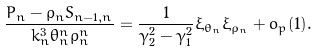Convert formula to latex. <formula><loc_0><loc_0><loc_500><loc_500>\frac { P _ { n } - \rho _ { n } S _ { n - 1 , n } } { k _ { n } ^ { 3 } \theta _ { n } ^ { n } \rho _ { n } ^ { n } } = \frac { 1 } { \gamma _ { 2 } ^ { 2 } - \gamma _ { 1 } ^ { 2 } } \xi _ { \theta _ { n } } \xi _ { \rho _ { n } } + o _ { p } { ( 1 ) } .</formula> 